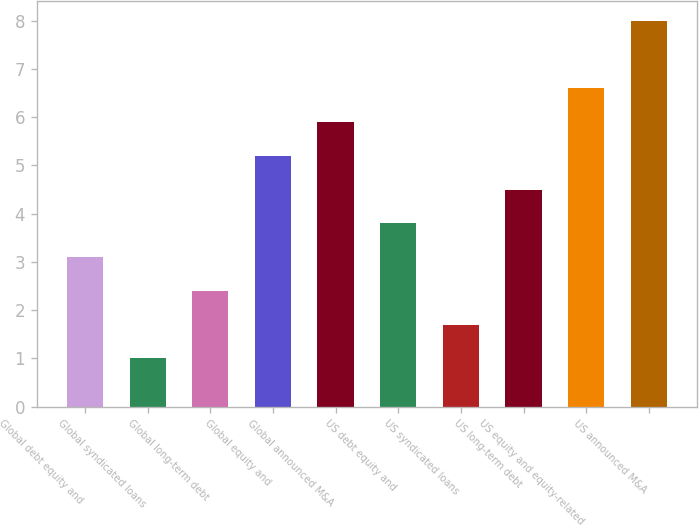Convert chart. <chart><loc_0><loc_0><loc_500><loc_500><bar_chart><fcel>Global debt equity and<fcel>Global syndicated loans<fcel>Global long-term debt<fcel>Global equity and<fcel>Global announced M&A<fcel>US debt equity and<fcel>US syndicated loans<fcel>US long-term debt<fcel>US equity and equity-related<fcel>US announced M&A<nl><fcel>3.1<fcel>1<fcel>2.4<fcel>5.2<fcel>5.9<fcel>3.8<fcel>1.7<fcel>4.5<fcel>6.6<fcel>8<nl></chart> 